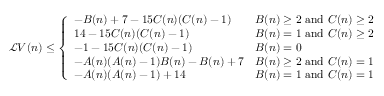<formula> <loc_0><loc_0><loc_500><loc_500>\begin{array} { r } { \mathcal { L } V ( n ) \leq \left \{ \begin{array} { l l } { - B ( n ) + 7 - 1 5 C ( n ) ( C ( n ) - 1 ) } & { B ( n ) \geq 2 a n d C ( n ) \geq 2 } \\ { 1 4 - 1 5 C ( n ) ( C ( n ) - 1 ) } & { B ( n ) = 1 a n d C ( n ) \geq 2 } \\ { - 1 - 1 5 C ( n ) ( C ( n ) - 1 ) } & { B ( n ) = 0 } \\ { - A ( n ) ( A ( n ) - 1 ) B ( n ) - B ( n ) + 7 } & { B ( n ) \geq 2 a n d C ( n ) = 1 } \\ { - A ( n ) ( A ( n ) - 1 ) + 1 4 } & { B ( n ) = 1 a n d C ( n ) = 1 } \end{array} } \end{array}</formula> 